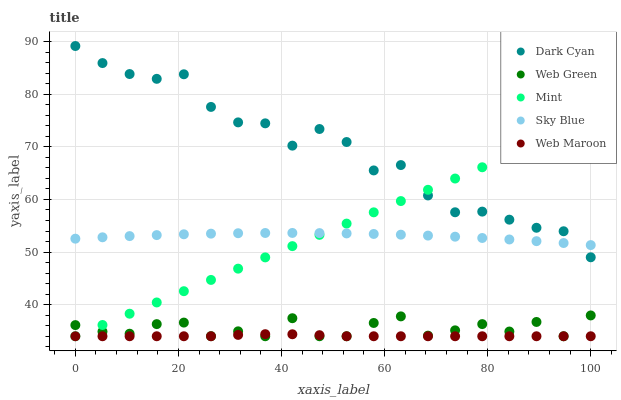Does Web Maroon have the minimum area under the curve?
Answer yes or no. Yes. Does Dark Cyan have the maximum area under the curve?
Answer yes or no. Yes. Does Sky Blue have the minimum area under the curve?
Answer yes or no. No. Does Sky Blue have the maximum area under the curve?
Answer yes or no. No. Is Mint the smoothest?
Answer yes or no. Yes. Is Dark Cyan the roughest?
Answer yes or no. Yes. Is Sky Blue the smoothest?
Answer yes or no. No. Is Sky Blue the roughest?
Answer yes or no. No. Does Mint have the lowest value?
Answer yes or no. Yes. Does Sky Blue have the lowest value?
Answer yes or no. No. Does Dark Cyan have the highest value?
Answer yes or no. Yes. Does Sky Blue have the highest value?
Answer yes or no. No. Is Web Maroon less than Sky Blue?
Answer yes or no. Yes. Is Sky Blue greater than Web Green?
Answer yes or no. Yes. Does Sky Blue intersect Mint?
Answer yes or no. Yes. Is Sky Blue less than Mint?
Answer yes or no. No. Is Sky Blue greater than Mint?
Answer yes or no. No. Does Web Maroon intersect Sky Blue?
Answer yes or no. No. 